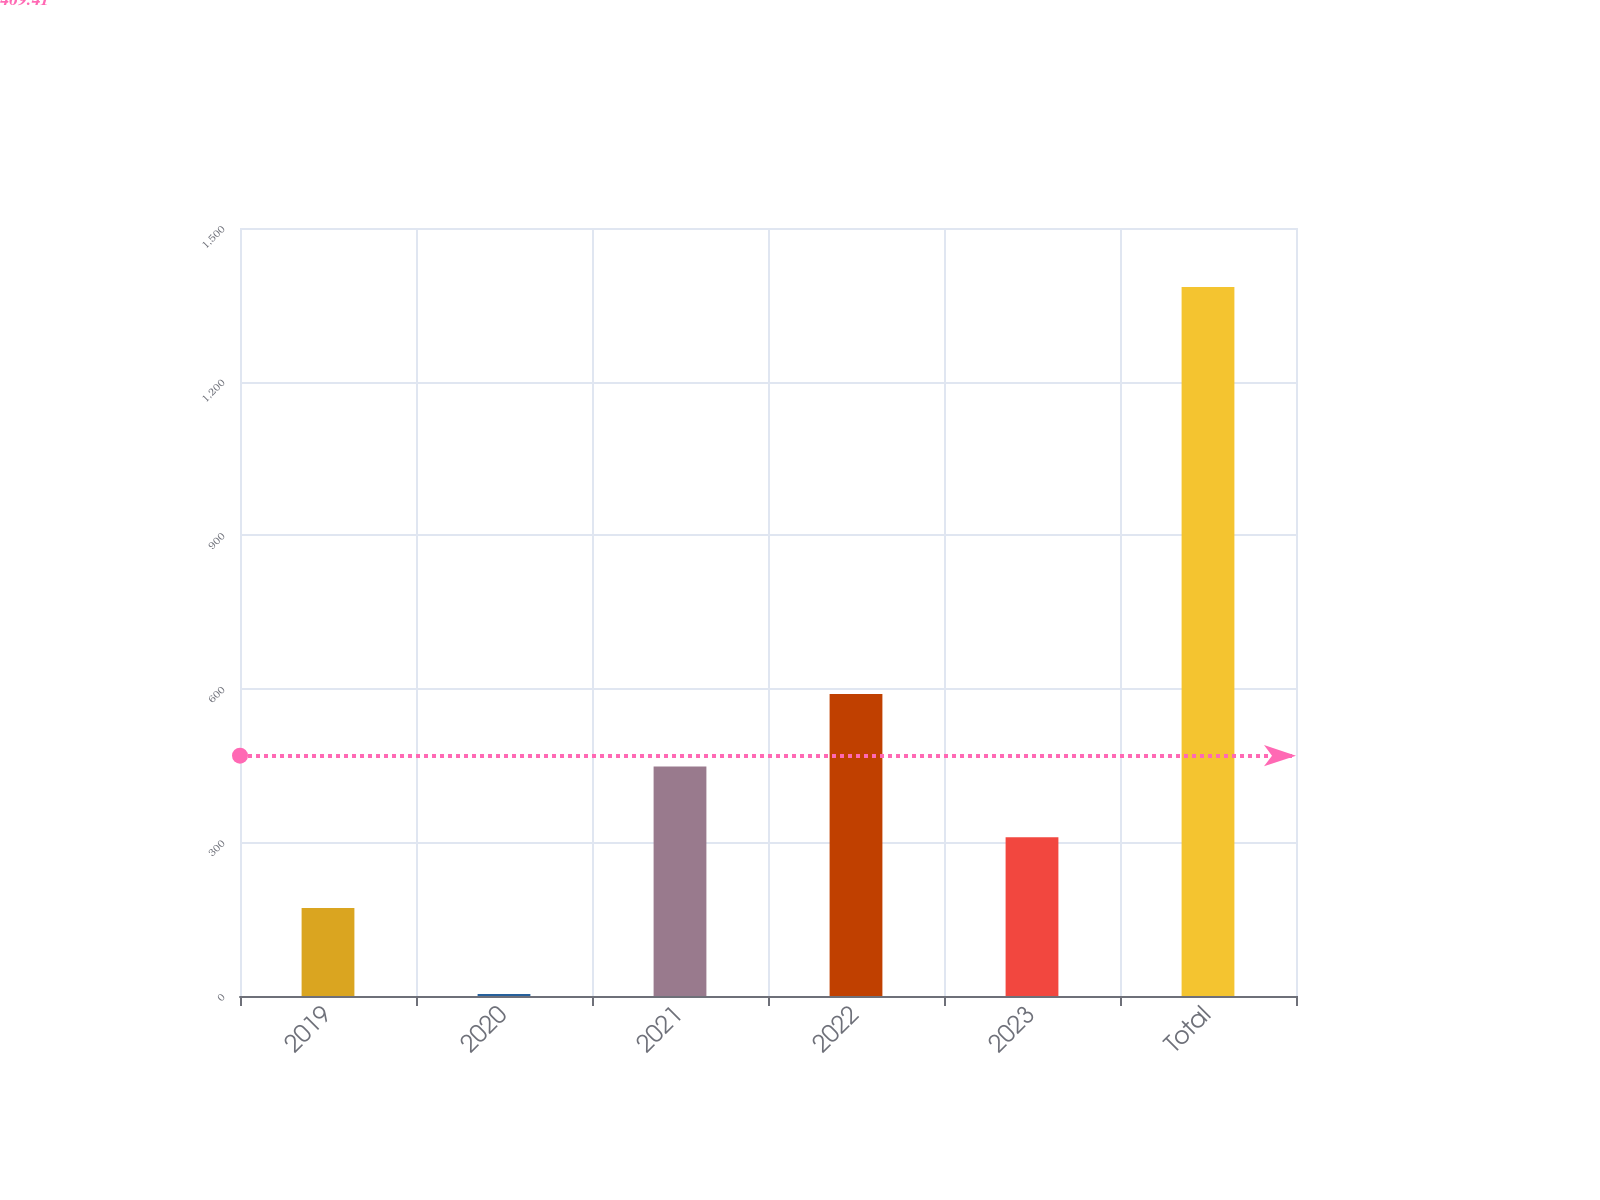Convert chart. <chart><loc_0><loc_0><loc_500><loc_500><bar_chart><fcel>2019<fcel>2020<fcel>2021<fcel>2022<fcel>2023<fcel>Total<nl><fcel>172<fcel>3.98<fcel>448.2<fcel>590<fcel>310.1<fcel>1385<nl></chart> 